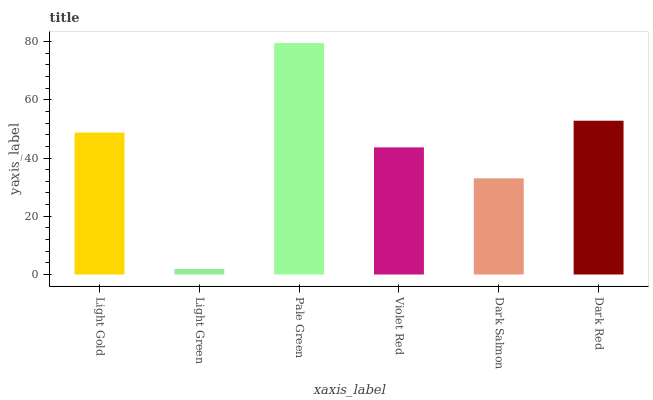Is Light Green the minimum?
Answer yes or no. Yes. Is Pale Green the maximum?
Answer yes or no. Yes. Is Pale Green the minimum?
Answer yes or no. No. Is Light Green the maximum?
Answer yes or no. No. Is Pale Green greater than Light Green?
Answer yes or no. Yes. Is Light Green less than Pale Green?
Answer yes or no. Yes. Is Light Green greater than Pale Green?
Answer yes or no. No. Is Pale Green less than Light Green?
Answer yes or no. No. Is Light Gold the high median?
Answer yes or no. Yes. Is Violet Red the low median?
Answer yes or no. Yes. Is Violet Red the high median?
Answer yes or no. No. Is Dark Red the low median?
Answer yes or no. No. 